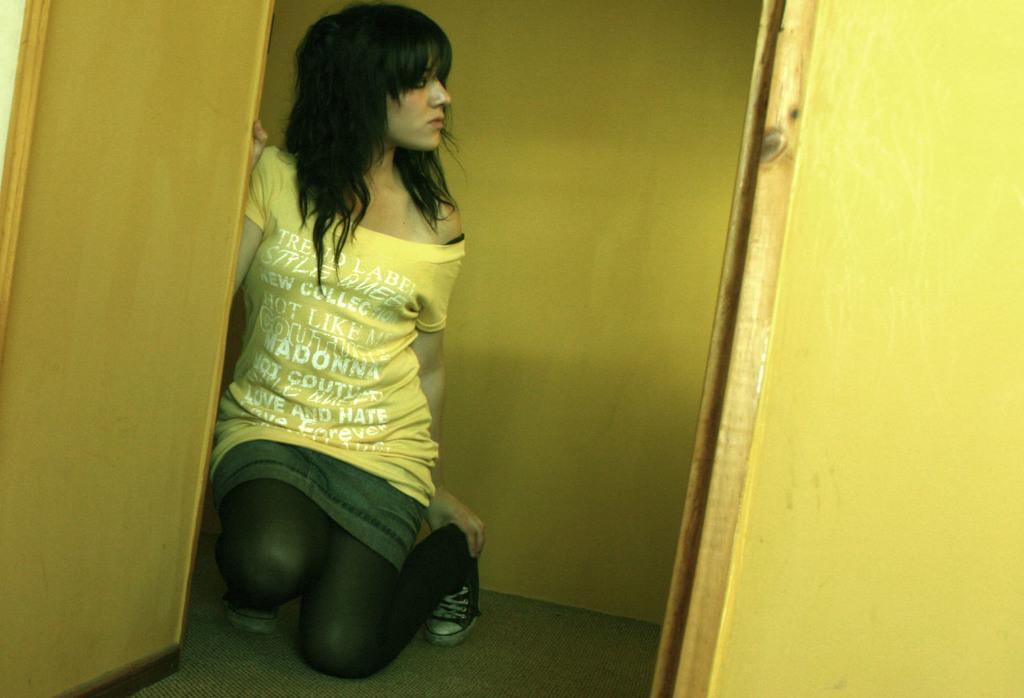Please provide a concise description of this image. In this image I can see a woman, wearing a yellow t shirt. There are yellow walls. 